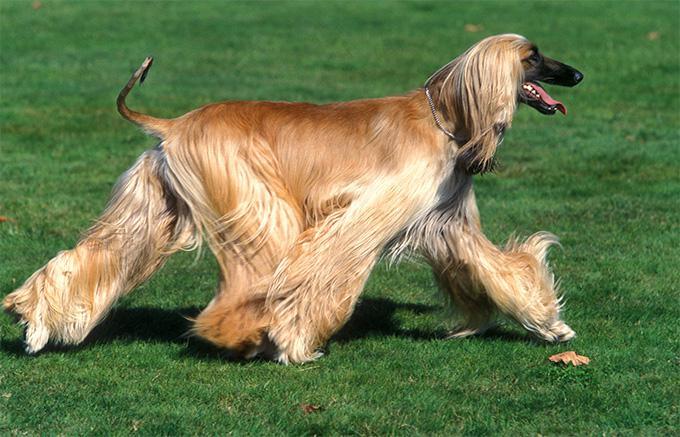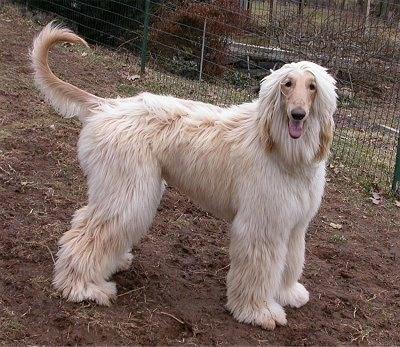The first image is the image on the left, the second image is the image on the right. For the images displayed, is the sentence "An image features an afghan hound on green grass." factually correct? Answer yes or no. Yes. 